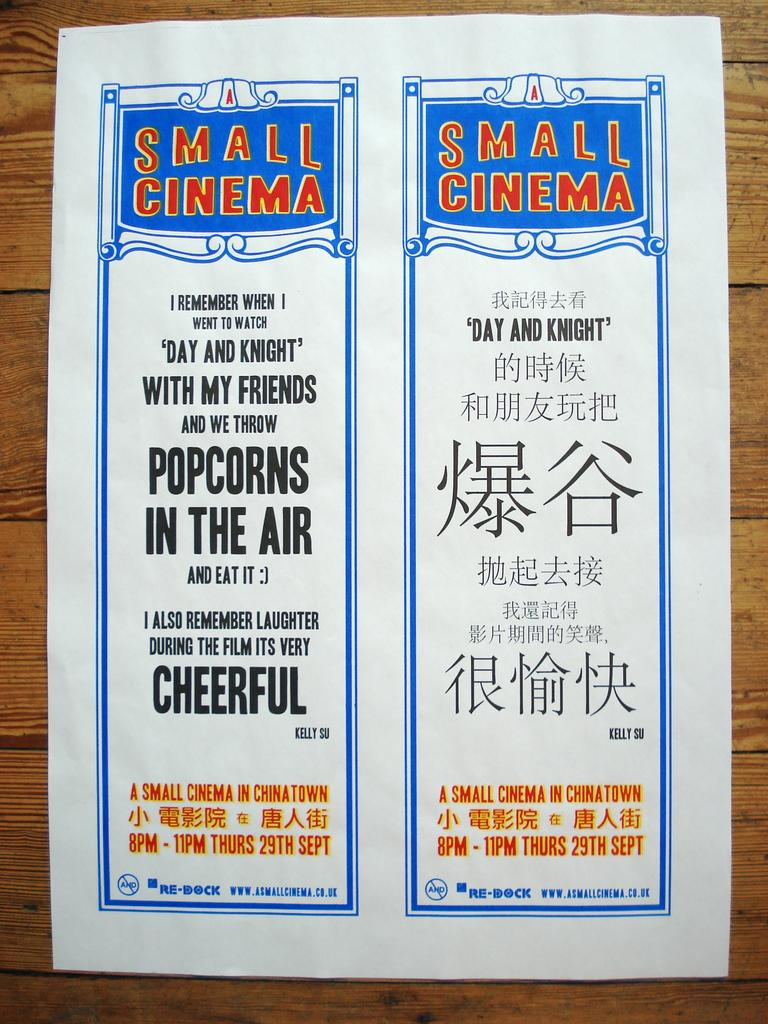<image>
Provide a brief description of the given image. a paper on a table that says 'a small cinema' on the top 